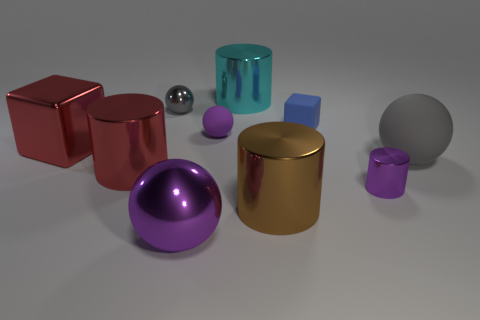Subtract all gray rubber balls. How many balls are left? 3 Subtract 2 cylinders. How many cylinders are left? 2 Subtract all blue blocks. How many blocks are left? 1 Subtract all cylinders. How many objects are left? 6 Subtract 0 brown blocks. How many objects are left? 10 Subtract all green cylinders. Subtract all brown blocks. How many cylinders are left? 4 Subtract all cyan cylinders. How many red blocks are left? 1 Subtract all shiny objects. Subtract all gray rubber things. How many objects are left? 2 Add 5 gray rubber spheres. How many gray rubber spheres are left? 6 Add 3 tiny blue blocks. How many tiny blue blocks exist? 4 